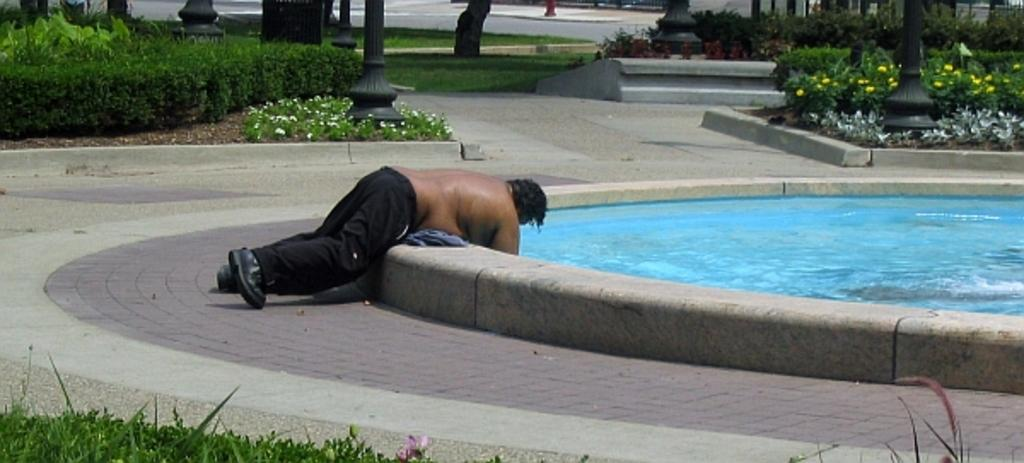What is the person in the image doing? The person is lying on the pavement of a swimming pool. What can be seen in the background of the image? There are bushes, plants, flowers, pillars, and a road visible in the background of the image. What type of riddle is the person trying to solve while lying on the pavement of the swimming pool? There is no indication in the image that the person is trying to solve a riddle; they are simply lying on the pavement. 